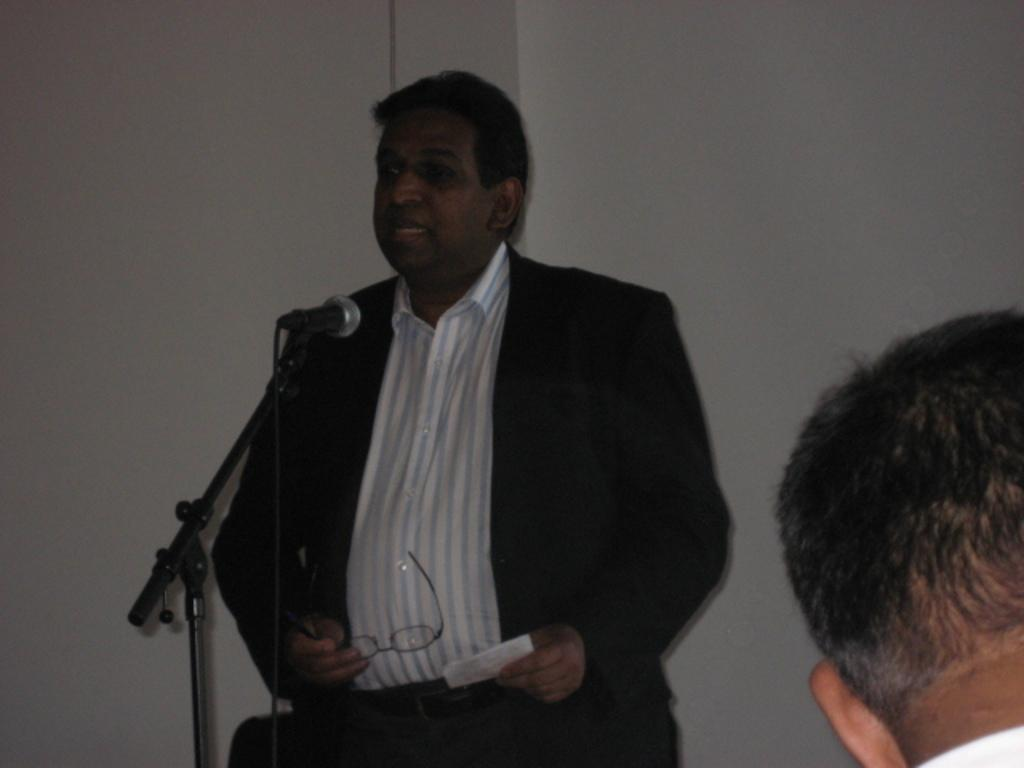What is the person in the image doing? The person in the image is speaking. What is the person holding while speaking? The person is holding a microphone and a paper in one hand, and spectacles in the other hand. Can you describe the other person visible in the image? There is another man's head visible in front of the speaker. What type of grass can be seen growing on the day in the image? There is no grass or reference to a day in the image; it features a person speaking with various objects in their hands. 